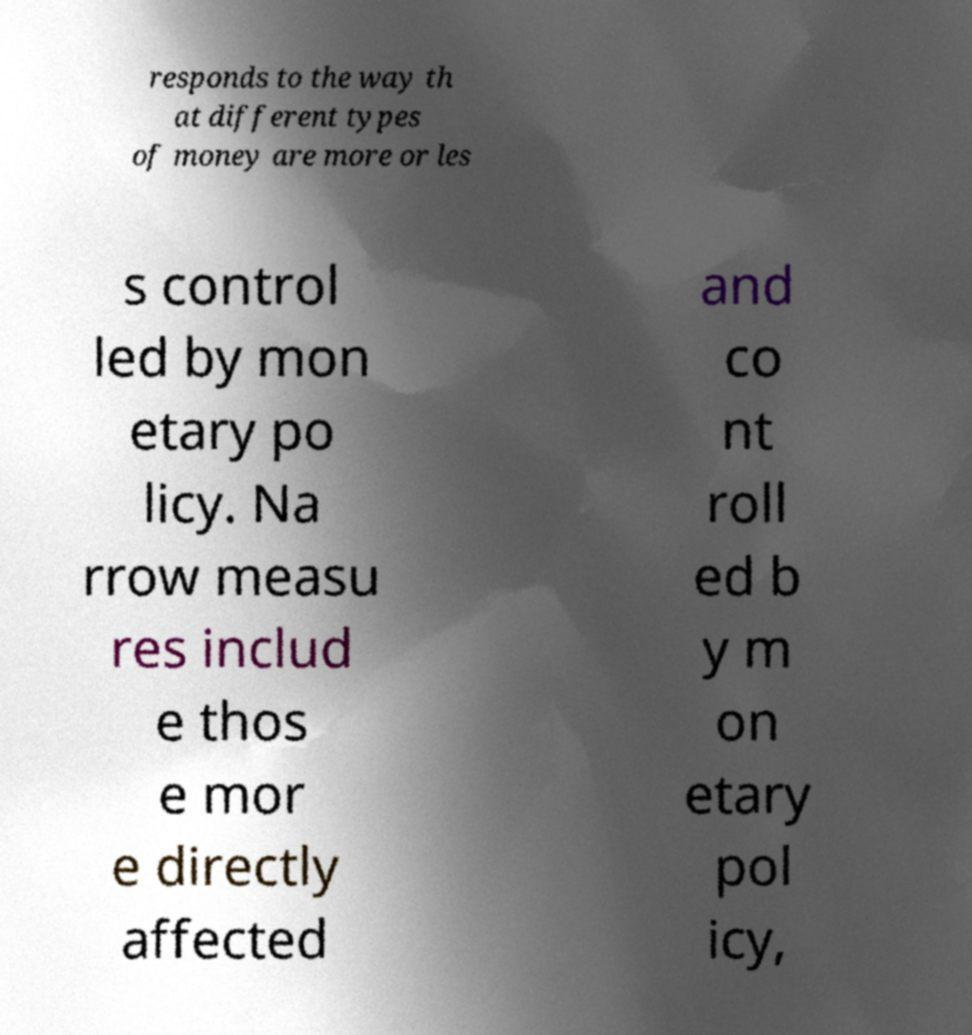Please identify and transcribe the text found in this image. responds to the way th at different types of money are more or les s control led by mon etary po licy. Na rrow measu res includ e thos e mor e directly affected and co nt roll ed b y m on etary pol icy, 